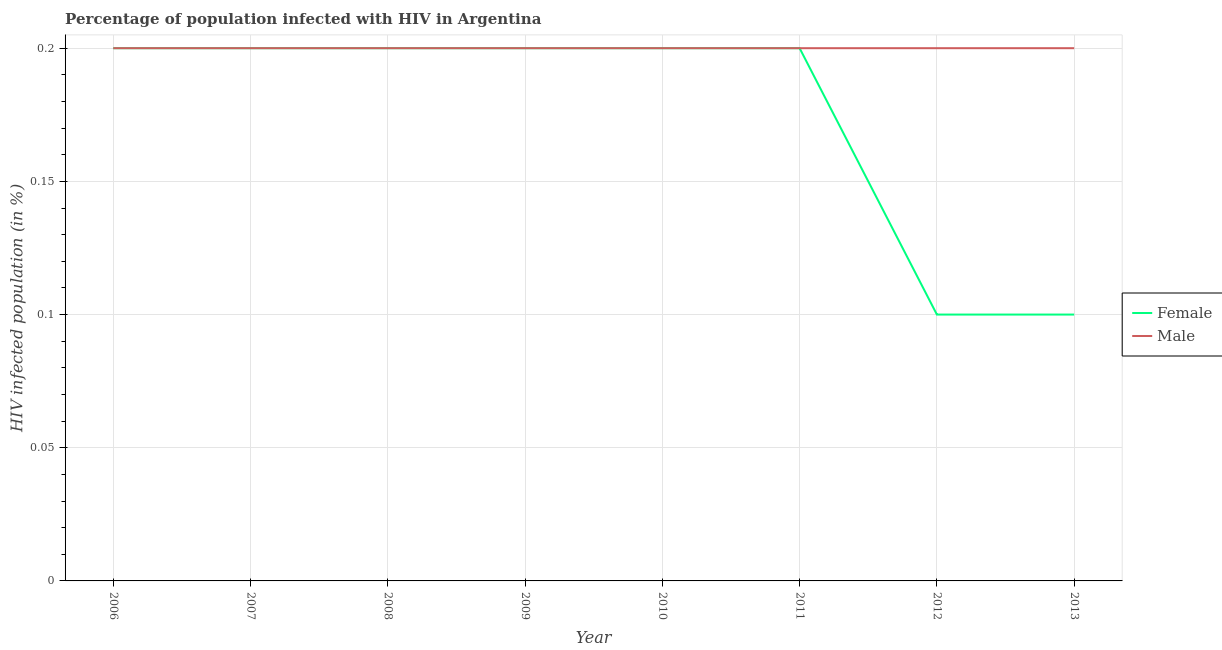What is the percentage of females who are infected with hiv in 2013?
Your response must be concise. 0.1. Across all years, what is the maximum percentage of females who are infected with hiv?
Your answer should be very brief. 0.2. Across all years, what is the minimum percentage of females who are infected with hiv?
Offer a terse response. 0.1. In which year was the percentage of males who are infected with hiv maximum?
Keep it short and to the point. 2006. What is the total percentage of females who are infected with hiv in the graph?
Provide a short and direct response. 1.4. What is the difference between the percentage of females who are infected with hiv in 2006 and that in 2013?
Your response must be concise. 0.1. What is the average percentage of females who are infected with hiv per year?
Your answer should be very brief. 0.18. In the year 2007, what is the difference between the percentage of females who are infected with hiv and percentage of males who are infected with hiv?
Give a very brief answer. 0. What is the ratio of the percentage of females who are infected with hiv in 2011 to that in 2013?
Ensure brevity in your answer.  2. Is the difference between the percentage of males who are infected with hiv in 2008 and 2010 greater than the difference between the percentage of females who are infected with hiv in 2008 and 2010?
Give a very brief answer. No. What is the difference between the highest and the second highest percentage of females who are infected with hiv?
Your response must be concise. 0. Is the percentage of males who are infected with hiv strictly greater than the percentage of females who are infected with hiv over the years?
Your response must be concise. No. Is the percentage of males who are infected with hiv strictly less than the percentage of females who are infected with hiv over the years?
Offer a very short reply. No. How many lines are there?
Give a very brief answer. 2. Are the values on the major ticks of Y-axis written in scientific E-notation?
Offer a very short reply. No. Does the graph contain any zero values?
Offer a terse response. No. Does the graph contain grids?
Your response must be concise. Yes. Where does the legend appear in the graph?
Make the answer very short. Center right. How many legend labels are there?
Ensure brevity in your answer.  2. What is the title of the graph?
Give a very brief answer. Percentage of population infected with HIV in Argentina. What is the label or title of the X-axis?
Make the answer very short. Year. What is the label or title of the Y-axis?
Keep it short and to the point. HIV infected population (in %). What is the HIV infected population (in %) of Female in 2007?
Ensure brevity in your answer.  0.2. What is the HIV infected population (in %) of Male in 2007?
Give a very brief answer. 0.2. What is the HIV infected population (in %) in Male in 2008?
Ensure brevity in your answer.  0.2. What is the HIV infected population (in %) in Female in 2009?
Make the answer very short. 0.2. What is the HIV infected population (in %) in Male in 2009?
Your response must be concise. 0.2. What is the HIV infected population (in %) of Female in 2011?
Ensure brevity in your answer.  0.2. What is the HIV infected population (in %) in Male in 2012?
Your response must be concise. 0.2. What is the HIV infected population (in %) of Female in 2013?
Provide a succinct answer. 0.1. Across all years, what is the maximum HIV infected population (in %) of Female?
Provide a succinct answer. 0.2. Across all years, what is the maximum HIV infected population (in %) in Male?
Keep it short and to the point. 0.2. Across all years, what is the minimum HIV infected population (in %) of Female?
Offer a terse response. 0.1. Across all years, what is the minimum HIV infected population (in %) of Male?
Your response must be concise. 0.2. What is the total HIV infected population (in %) of Female in the graph?
Offer a terse response. 1.4. What is the total HIV infected population (in %) of Male in the graph?
Keep it short and to the point. 1.6. What is the difference between the HIV infected population (in %) in Male in 2006 and that in 2007?
Ensure brevity in your answer.  0. What is the difference between the HIV infected population (in %) of Female in 2006 and that in 2009?
Provide a short and direct response. 0. What is the difference between the HIV infected population (in %) in Male in 2006 and that in 2009?
Provide a succinct answer. 0. What is the difference between the HIV infected population (in %) in Female in 2006 and that in 2010?
Ensure brevity in your answer.  0. What is the difference between the HIV infected population (in %) of Female in 2006 and that in 2011?
Make the answer very short. 0. What is the difference between the HIV infected population (in %) of Female in 2006 and that in 2012?
Give a very brief answer. 0.1. What is the difference between the HIV infected population (in %) in Female in 2006 and that in 2013?
Ensure brevity in your answer.  0.1. What is the difference between the HIV infected population (in %) of Male in 2006 and that in 2013?
Provide a short and direct response. 0. What is the difference between the HIV infected population (in %) in Female in 2007 and that in 2008?
Offer a terse response. 0. What is the difference between the HIV infected population (in %) of Female in 2007 and that in 2009?
Offer a very short reply. 0. What is the difference between the HIV infected population (in %) in Male in 2007 and that in 2009?
Provide a short and direct response. 0. What is the difference between the HIV infected population (in %) in Male in 2007 and that in 2010?
Keep it short and to the point. 0. What is the difference between the HIV infected population (in %) of Male in 2007 and that in 2011?
Offer a very short reply. 0. What is the difference between the HIV infected population (in %) of Female in 2007 and that in 2012?
Make the answer very short. 0.1. What is the difference between the HIV infected population (in %) of Male in 2007 and that in 2012?
Offer a terse response. 0. What is the difference between the HIV infected population (in %) in Female in 2007 and that in 2013?
Keep it short and to the point. 0.1. What is the difference between the HIV infected population (in %) of Male in 2007 and that in 2013?
Your answer should be very brief. 0. What is the difference between the HIV infected population (in %) in Male in 2008 and that in 2010?
Your answer should be very brief. 0. What is the difference between the HIV infected population (in %) in Female in 2008 and that in 2011?
Offer a very short reply. 0. What is the difference between the HIV infected population (in %) of Female in 2008 and that in 2013?
Ensure brevity in your answer.  0.1. What is the difference between the HIV infected population (in %) of Male in 2008 and that in 2013?
Ensure brevity in your answer.  0. What is the difference between the HIV infected population (in %) in Female in 2009 and that in 2010?
Offer a very short reply. 0. What is the difference between the HIV infected population (in %) of Male in 2009 and that in 2011?
Offer a very short reply. 0. What is the difference between the HIV infected population (in %) of Female in 2009 and that in 2012?
Give a very brief answer. 0.1. What is the difference between the HIV infected population (in %) of Male in 2009 and that in 2012?
Offer a terse response. 0. What is the difference between the HIV infected population (in %) in Male in 2009 and that in 2013?
Make the answer very short. 0. What is the difference between the HIV infected population (in %) in Female in 2010 and that in 2011?
Make the answer very short. 0. What is the difference between the HIV infected population (in %) of Female in 2010 and that in 2013?
Offer a very short reply. 0.1. What is the difference between the HIV infected population (in %) in Male in 2010 and that in 2013?
Offer a terse response. 0. What is the difference between the HIV infected population (in %) of Male in 2011 and that in 2012?
Provide a succinct answer. 0. What is the difference between the HIV infected population (in %) in Female in 2011 and that in 2013?
Your response must be concise. 0.1. What is the difference between the HIV infected population (in %) in Female in 2006 and the HIV infected population (in %) in Male in 2007?
Your answer should be compact. 0. What is the difference between the HIV infected population (in %) of Female in 2006 and the HIV infected population (in %) of Male in 2012?
Your answer should be compact. 0. What is the difference between the HIV infected population (in %) of Female in 2006 and the HIV infected population (in %) of Male in 2013?
Make the answer very short. 0. What is the difference between the HIV infected population (in %) of Female in 2007 and the HIV infected population (in %) of Male in 2008?
Offer a terse response. 0. What is the difference between the HIV infected population (in %) of Female in 2007 and the HIV infected population (in %) of Male in 2009?
Ensure brevity in your answer.  0. What is the difference between the HIV infected population (in %) of Female in 2007 and the HIV infected population (in %) of Male in 2010?
Keep it short and to the point. 0. What is the difference between the HIV infected population (in %) of Female in 2007 and the HIV infected population (in %) of Male in 2011?
Offer a terse response. 0. What is the difference between the HIV infected population (in %) of Female in 2007 and the HIV infected population (in %) of Male in 2012?
Your answer should be very brief. 0. What is the difference between the HIV infected population (in %) in Female in 2007 and the HIV infected population (in %) in Male in 2013?
Offer a terse response. 0. What is the difference between the HIV infected population (in %) in Female in 2008 and the HIV infected population (in %) in Male in 2009?
Provide a succinct answer. 0. What is the difference between the HIV infected population (in %) in Female in 2008 and the HIV infected population (in %) in Male in 2010?
Your response must be concise. 0. What is the difference between the HIV infected population (in %) of Female in 2008 and the HIV infected population (in %) of Male in 2011?
Provide a short and direct response. 0. What is the difference between the HIV infected population (in %) of Female in 2008 and the HIV infected population (in %) of Male in 2012?
Offer a very short reply. 0. What is the difference between the HIV infected population (in %) in Female in 2009 and the HIV infected population (in %) in Male in 2010?
Give a very brief answer. 0. What is the difference between the HIV infected population (in %) of Female in 2009 and the HIV infected population (in %) of Male in 2011?
Provide a short and direct response. 0. What is the difference between the HIV infected population (in %) of Female in 2010 and the HIV infected population (in %) of Male in 2011?
Offer a very short reply. 0. What is the difference between the HIV infected population (in %) in Female in 2010 and the HIV infected population (in %) in Male in 2012?
Keep it short and to the point. 0. What is the difference between the HIV infected population (in %) in Female in 2010 and the HIV infected population (in %) in Male in 2013?
Give a very brief answer. 0. What is the difference between the HIV infected population (in %) of Female in 2012 and the HIV infected population (in %) of Male in 2013?
Your response must be concise. -0.1. What is the average HIV infected population (in %) in Female per year?
Give a very brief answer. 0.17. In the year 2006, what is the difference between the HIV infected population (in %) in Female and HIV infected population (in %) in Male?
Make the answer very short. 0. In the year 2008, what is the difference between the HIV infected population (in %) of Female and HIV infected population (in %) of Male?
Your response must be concise. 0. What is the ratio of the HIV infected population (in %) in Male in 2006 to that in 2007?
Give a very brief answer. 1. What is the ratio of the HIV infected population (in %) in Female in 2006 to that in 2008?
Your answer should be very brief. 1. What is the ratio of the HIV infected population (in %) in Male in 2006 to that in 2008?
Give a very brief answer. 1. What is the ratio of the HIV infected population (in %) of Female in 2006 to that in 2010?
Ensure brevity in your answer.  1. What is the ratio of the HIV infected population (in %) in Female in 2006 to that in 2011?
Give a very brief answer. 1. What is the ratio of the HIV infected population (in %) in Female in 2006 to that in 2013?
Your answer should be very brief. 2. What is the ratio of the HIV infected population (in %) of Female in 2007 to that in 2008?
Make the answer very short. 1. What is the ratio of the HIV infected population (in %) in Male in 2007 to that in 2008?
Offer a terse response. 1. What is the ratio of the HIV infected population (in %) of Female in 2007 to that in 2009?
Make the answer very short. 1. What is the ratio of the HIV infected population (in %) in Male in 2007 to that in 2009?
Offer a very short reply. 1. What is the ratio of the HIV infected population (in %) in Female in 2007 to that in 2010?
Your answer should be very brief. 1. What is the ratio of the HIV infected population (in %) of Female in 2007 to that in 2011?
Your answer should be very brief. 1. What is the ratio of the HIV infected population (in %) in Male in 2007 to that in 2011?
Your answer should be very brief. 1. What is the ratio of the HIV infected population (in %) in Female in 2007 to that in 2013?
Ensure brevity in your answer.  2. What is the ratio of the HIV infected population (in %) of Male in 2007 to that in 2013?
Make the answer very short. 1. What is the ratio of the HIV infected population (in %) in Female in 2008 to that in 2009?
Offer a very short reply. 1. What is the ratio of the HIV infected population (in %) in Male in 2008 to that in 2009?
Provide a succinct answer. 1. What is the ratio of the HIV infected population (in %) of Male in 2008 to that in 2010?
Offer a terse response. 1. What is the ratio of the HIV infected population (in %) in Female in 2008 to that in 2011?
Your answer should be very brief. 1. What is the ratio of the HIV infected population (in %) in Male in 2008 to that in 2011?
Offer a very short reply. 1. What is the ratio of the HIV infected population (in %) in Male in 2008 to that in 2012?
Keep it short and to the point. 1. What is the ratio of the HIV infected population (in %) in Male in 2008 to that in 2013?
Offer a very short reply. 1. What is the ratio of the HIV infected population (in %) in Male in 2009 to that in 2010?
Your answer should be very brief. 1. What is the ratio of the HIV infected population (in %) of Female in 2009 to that in 2013?
Provide a short and direct response. 2. What is the ratio of the HIV infected population (in %) of Male in 2009 to that in 2013?
Offer a terse response. 1. What is the ratio of the HIV infected population (in %) of Male in 2010 to that in 2011?
Keep it short and to the point. 1. What is the ratio of the HIV infected population (in %) in Male in 2010 to that in 2012?
Provide a succinct answer. 1. What is the ratio of the HIV infected population (in %) of Female in 2011 to that in 2012?
Ensure brevity in your answer.  2. What is the ratio of the HIV infected population (in %) in Male in 2011 to that in 2012?
Your answer should be very brief. 1. What is the ratio of the HIV infected population (in %) of Female in 2011 to that in 2013?
Provide a succinct answer. 2. What is the ratio of the HIV infected population (in %) of Female in 2012 to that in 2013?
Provide a succinct answer. 1. What is the ratio of the HIV infected population (in %) of Male in 2012 to that in 2013?
Ensure brevity in your answer.  1. What is the difference between the highest and the second highest HIV infected population (in %) of Male?
Make the answer very short. 0. What is the difference between the highest and the lowest HIV infected population (in %) in Female?
Make the answer very short. 0.1. 